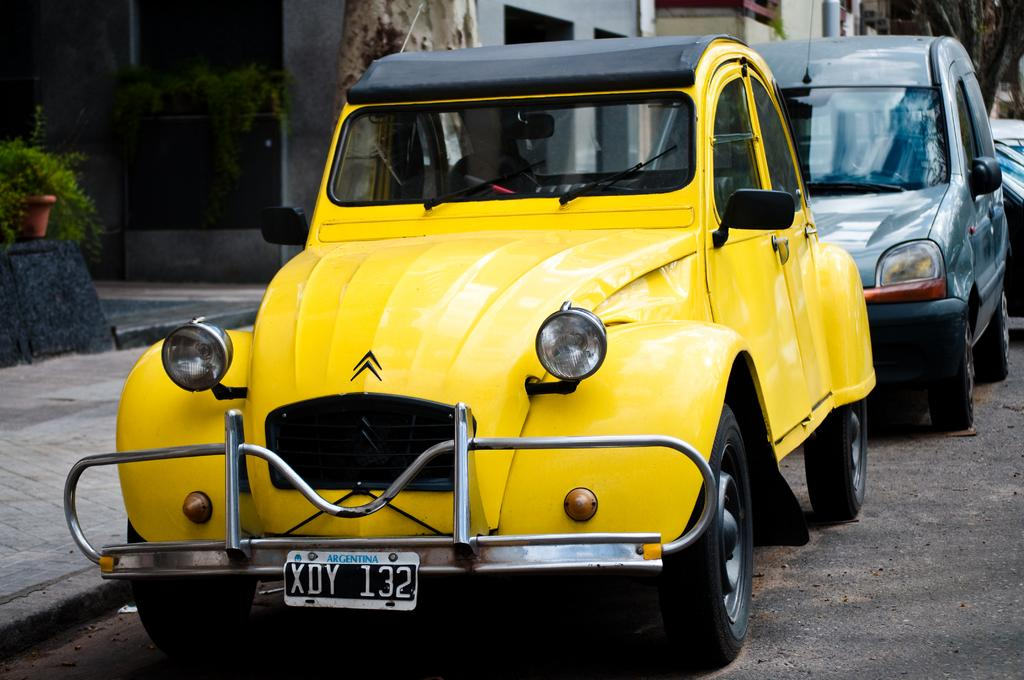<image>
Offer a succinct explanation of the picture presented. A vintage yellow car with a black convertible top has the license plate XDY 132 